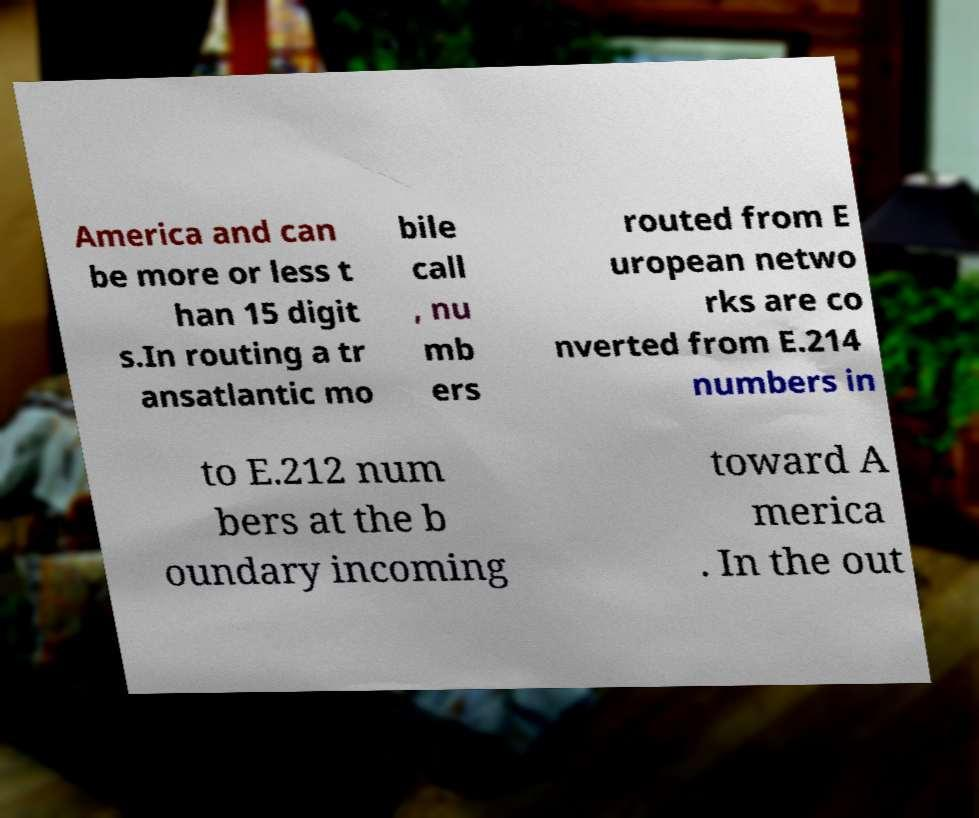I need the written content from this picture converted into text. Can you do that? America and can be more or less t han 15 digit s.In routing a tr ansatlantic mo bile call , nu mb ers routed from E uropean netwo rks are co nverted from E.214 numbers in to E.212 num bers at the b oundary incoming toward A merica . In the out 